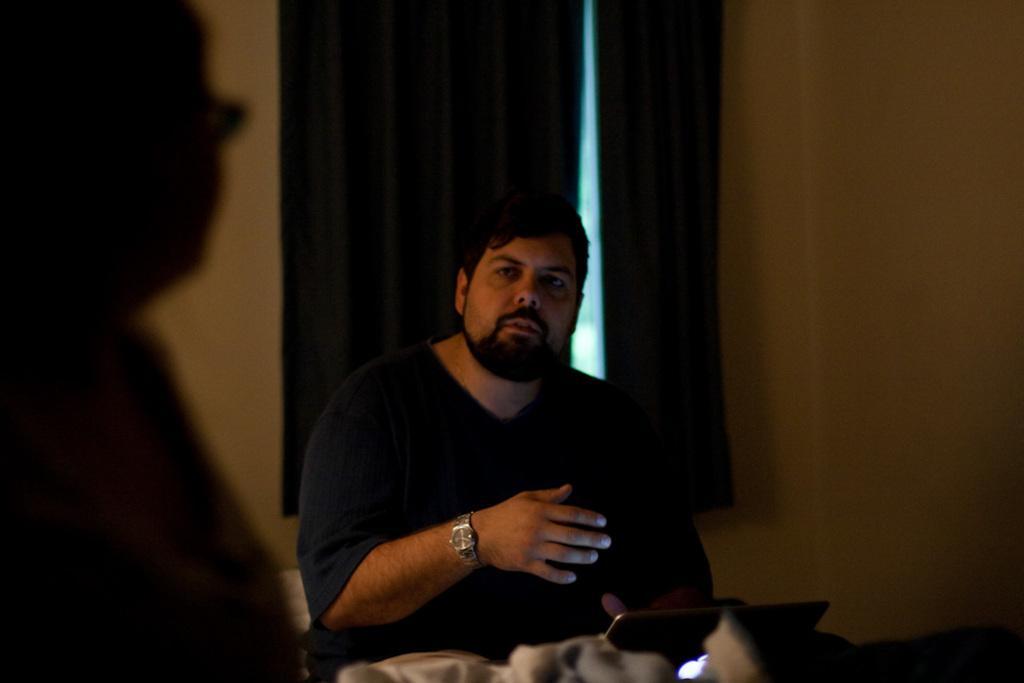Please provide a concise description of this image. In this picture I can see a man seated and I can see a laptop and couple of curtains to the window and I can see a shadow of a human on the wall. 